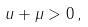Convert formula to latex. <formula><loc_0><loc_0><loc_500><loc_500>u + \mu > 0 \, ,</formula> 